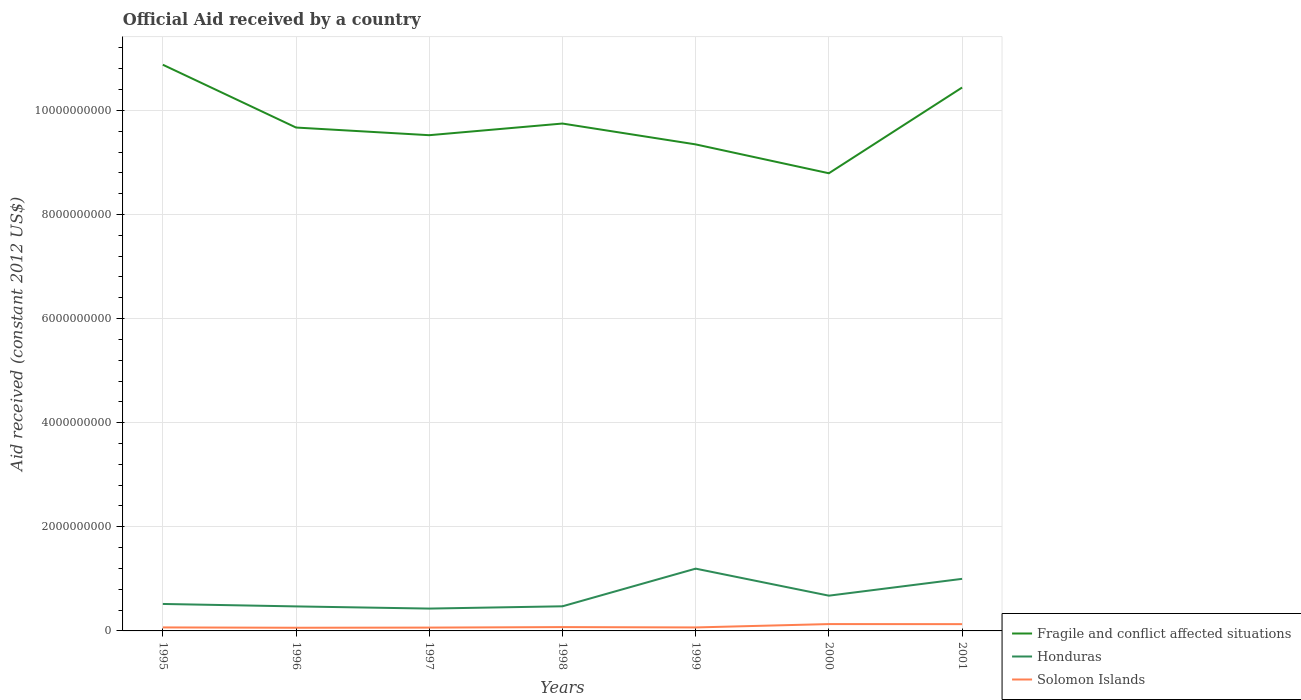How many different coloured lines are there?
Offer a terse response. 3. Does the line corresponding to Fragile and conflict affected situations intersect with the line corresponding to Solomon Islands?
Your response must be concise. No. Across all years, what is the maximum net official aid received in Honduras?
Give a very brief answer. 4.29e+08. What is the total net official aid received in Honduras in the graph?
Provide a succinct answer. 5.19e+08. What is the difference between the highest and the second highest net official aid received in Honduras?
Provide a succinct answer. 7.67e+08. How many lines are there?
Ensure brevity in your answer.  3. How many years are there in the graph?
Give a very brief answer. 7. Where does the legend appear in the graph?
Offer a terse response. Bottom right. How are the legend labels stacked?
Offer a terse response. Vertical. What is the title of the graph?
Your response must be concise. Official Aid received by a country. Does "Haiti" appear as one of the legend labels in the graph?
Your answer should be compact. No. What is the label or title of the Y-axis?
Make the answer very short. Aid received (constant 2012 US$). What is the Aid received (constant 2012 US$) of Fragile and conflict affected situations in 1995?
Provide a short and direct response. 1.09e+1. What is the Aid received (constant 2012 US$) of Honduras in 1995?
Your answer should be very brief. 5.18e+08. What is the Aid received (constant 2012 US$) in Solomon Islands in 1995?
Keep it short and to the point. 6.73e+07. What is the Aid received (constant 2012 US$) of Fragile and conflict affected situations in 1996?
Give a very brief answer. 9.67e+09. What is the Aid received (constant 2012 US$) of Honduras in 1996?
Your answer should be very brief. 4.71e+08. What is the Aid received (constant 2012 US$) of Solomon Islands in 1996?
Ensure brevity in your answer.  6.09e+07. What is the Aid received (constant 2012 US$) of Fragile and conflict affected situations in 1997?
Your response must be concise. 9.52e+09. What is the Aid received (constant 2012 US$) of Honduras in 1997?
Your answer should be very brief. 4.29e+08. What is the Aid received (constant 2012 US$) of Solomon Islands in 1997?
Offer a very short reply. 6.41e+07. What is the Aid received (constant 2012 US$) in Fragile and conflict affected situations in 1998?
Offer a very short reply. 9.75e+09. What is the Aid received (constant 2012 US$) of Honduras in 1998?
Your response must be concise. 4.73e+08. What is the Aid received (constant 2012 US$) of Solomon Islands in 1998?
Your answer should be compact. 7.36e+07. What is the Aid received (constant 2012 US$) in Fragile and conflict affected situations in 1999?
Your answer should be compact. 9.35e+09. What is the Aid received (constant 2012 US$) of Honduras in 1999?
Keep it short and to the point. 1.20e+09. What is the Aid received (constant 2012 US$) in Solomon Islands in 1999?
Provide a succinct answer. 6.69e+07. What is the Aid received (constant 2012 US$) of Fragile and conflict affected situations in 2000?
Provide a short and direct response. 8.79e+09. What is the Aid received (constant 2012 US$) of Honduras in 2000?
Your answer should be very brief. 6.77e+08. What is the Aid received (constant 2012 US$) of Solomon Islands in 2000?
Your response must be concise. 1.32e+08. What is the Aid received (constant 2012 US$) of Fragile and conflict affected situations in 2001?
Your response must be concise. 1.04e+1. What is the Aid received (constant 2012 US$) of Honduras in 2001?
Keep it short and to the point. 1.00e+09. What is the Aid received (constant 2012 US$) of Solomon Islands in 2001?
Keep it short and to the point. 1.30e+08. Across all years, what is the maximum Aid received (constant 2012 US$) of Fragile and conflict affected situations?
Make the answer very short. 1.09e+1. Across all years, what is the maximum Aid received (constant 2012 US$) in Honduras?
Ensure brevity in your answer.  1.20e+09. Across all years, what is the maximum Aid received (constant 2012 US$) of Solomon Islands?
Your answer should be very brief. 1.32e+08. Across all years, what is the minimum Aid received (constant 2012 US$) in Fragile and conflict affected situations?
Your response must be concise. 8.79e+09. Across all years, what is the minimum Aid received (constant 2012 US$) in Honduras?
Offer a terse response. 4.29e+08. Across all years, what is the minimum Aid received (constant 2012 US$) in Solomon Islands?
Keep it short and to the point. 6.09e+07. What is the total Aid received (constant 2012 US$) in Fragile and conflict affected situations in the graph?
Ensure brevity in your answer.  6.84e+1. What is the total Aid received (constant 2012 US$) in Honduras in the graph?
Give a very brief answer. 4.77e+09. What is the total Aid received (constant 2012 US$) in Solomon Islands in the graph?
Provide a short and direct response. 5.95e+08. What is the difference between the Aid received (constant 2012 US$) in Fragile and conflict affected situations in 1995 and that in 1996?
Provide a short and direct response. 1.21e+09. What is the difference between the Aid received (constant 2012 US$) in Honduras in 1995 and that in 1996?
Your answer should be very brief. 4.69e+07. What is the difference between the Aid received (constant 2012 US$) in Solomon Islands in 1995 and that in 1996?
Your answer should be compact. 6.45e+06. What is the difference between the Aid received (constant 2012 US$) in Fragile and conflict affected situations in 1995 and that in 1997?
Offer a terse response. 1.35e+09. What is the difference between the Aid received (constant 2012 US$) in Honduras in 1995 and that in 1997?
Your response must be concise. 8.87e+07. What is the difference between the Aid received (constant 2012 US$) of Solomon Islands in 1995 and that in 1997?
Your response must be concise. 3.24e+06. What is the difference between the Aid received (constant 2012 US$) in Fragile and conflict affected situations in 1995 and that in 1998?
Provide a short and direct response. 1.13e+09. What is the difference between the Aid received (constant 2012 US$) of Honduras in 1995 and that in 1998?
Your answer should be compact. 4.49e+07. What is the difference between the Aid received (constant 2012 US$) of Solomon Islands in 1995 and that in 1998?
Provide a short and direct response. -6.33e+06. What is the difference between the Aid received (constant 2012 US$) of Fragile and conflict affected situations in 1995 and that in 1999?
Offer a terse response. 1.53e+09. What is the difference between the Aid received (constant 2012 US$) in Honduras in 1995 and that in 1999?
Make the answer very short. -6.78e+08. What is the difference between the Aid received (constant 2012 US$) in Fragile and conflict affected situations in 1995 and that in 2000?
Keep it short and to the point. 2.08e+09. What is the difference between the Aid received (constant 2012 US$) in Honduras in 1995 and that in 2000?
Provide a succinct answer. -1.59e+08. What is the difference between the Aid received (constant 2012 US$) in Solomon Islands in 1995 and that in 2000?
Provide a short and direct response. -6.42e+07. What is the difference between the Aid received (constant 2012 US$) of Fragile and conflict affected situations in 1995 and that in 2001?
Keep it short and to the point. 4.38e+08. What is the difference between the Aid received (constant 2012 US$) in Honduras in 1995 and that in 2001?
Your answer should be compact. -4.82e+08. What is the difference between the Aid received (constant 2012 US$) in Solomon Islands in 1995 and that in 2001?
Your response must be concise. -6.29e+07. What is the difference between the Aid received (constant 2012 US$) in Fragile and conflict affected situations in 1996 and that in 1997?
Offer a very short reply. 1.47e+08. What is the difference between the Aid received (constant 2012 US$) in Honduras in 1996 and that in 1997?
Your response must be concise. 4.18e+07. What is the difference between the Aid received (constant 2012 US$) in Solomon Islands in 1996 and that in 1997?
Your response must be concise. -3.21e+06. What is the difference between the Aid received (constant 2012 US$) in Fragile and conflict affected situations in 1996 and that in 1998?
Offer a terse response. -7.68e+07. What is the difference between the Aid received (constant 2012 US$) in Solomon Islands in 1996 and that in 1998?
Provide a succinct answer. -1.28e+07. What is the difference between the Aid received (constant 2012 US$) in Fragile and conflict affected situations in 1996 and that in 1999?
Ensure brevity in your answer.  3.24e+08. What is the difference between the Aid received (constant 2012 US$) in Honduras in 1996 and that in 1999?
Make the answer very short. -7.25e+08. What is the difference between the Aid received (constant 2012 US$) in Solomon Islands in 1996 and that in 1999?
Your response must be concise. -6.04e+06. What is the difference between the Aid received (constant 2012 US$) in Fragile and conflict affected situations in 1996 and that in 2000?
Keep it short and to the point. 8.78e+08. What is the difference between the Aid received (constant 2012 US$) in Honduras in 1996 and that in 2000?
Provide a short and direct response. -2.06e+08. What is the difference between the Aid received (constant 2012 US$) in Solomon Islands in 1996 and that in 2000?
Your answer should be very brief. -7.07e+07. What is the difference between the Aid received (constant 2012 US$) of Fragile and conflict affected situations in 1996 and that in 2001?
Provide a succinct answer. -7.69e+08. What is the difference between the Aid received (constant 2012 US$) in Honduras in 1996 and that in 2001?
Offer a terse response. -5.29e+08. What is the difference between the Aid received (constant 2012 US$) in Solomon Islands in 1996 and that in 2001?
Provide a succinct answer. -6.93e+07. What is the difference between the Aid received (constant 2012 US$) of Fragile and conflict affected situations in 1997 and that in 1998?
Provide a succinct answer. -2.24e+08. What is the difference between the Aid received (constant 2012 US$) in Honduras in 1997 and that in 1998?
Offer a terse response. -4.38e+07. What is the difference between the Aid received (constant 2012 US$) of Solomon Islands in 1997 and that in 1998?
Give a very brief answer. -9.57e+06. What is the difference between the Aid received (constant 2012 US$) in Fragile and conflict affected situations in 1997 and that in 1999?
Ensure brevity in your answer.  1.77e+08. What is the difference between the Aid received (constant 2012 US$) of Honduras in 1997 and that in 1999?
Your answer should be compact. -7.67e+08. What is the difference between the Aid received (constant 2012 US$) in Solomon Islands in 1997 and that in 1999?
Offer a terse response. -2.83e+06. What is the difference between the Aid received (constant 2012 US$) of Fragile and conflict affected situations in 1997 and that in 2000?
Offer a terse response. 7.31e+08. What is the difference between the Aid received (constant 2012 US$) in Honduras in 1997 and that in 2000?
Ensure brevity in your answer.  -2.48e+08. What is the difference between the Aid received (constant 2012 US$) of Solomon Islands in 1997 and that in 2000?
Provide a short and direct response. -6.75e+07. What is the difference between the Aid received (constant 2012 US$) of Fragile and conflict affected situations in 1997 and that in 2001?
Your answer should be very brief. -9.16e+08. What is the difference between the Aid received (constant 2012 US$) of Honduras in 1997 and that in 2001?
Provide a succinct answer. -5.71e+08. What is the difference between the Aid received (constant 2012 US$) of Solomon Islands in 1997 and that in 2001?
Give a very brief answer. -6.61e+07. What is the difference between the Aid received (constant 2012 US$) of Fragile and conflict affected situations in 1998 and that in 1999?
Offer a terse response. 4.01e+08. What is the difference between the Aid received (constant 2012 US$) of Honduras in 1998 and that in 1999?
Give a very brief answer. -7.23e+08. What is the difference between the Aid received (constant 2012 US$) of Solomon Islands in 1998 and that in 1999?
Provide a short and direct response. 6.74e+06. What is the difference between the Aid received (constant 2012 US$) of Fragile and conflict affected situations in 1998 and that in 2000?
Ensure brevity in your answer.  9.55e+08. What is the difference between the Aid received (constant 2012 US$) of Honduras in 1998 and that in 2000?
Give a very brief answer. -2.04e+08. What is the difference between the Aid received (constant 2012 US$) in Solomon Islands in 1998 and that in 2000?
Make the answer very short. -5.79e+07. What is the difference between the Aid received (constant 2012 US$) of Fragile and conflict affected situations in 1998 and that in 2001?
Provide a short and direct response. -6.92e+08. What is the difference between the Aid received (constant 2012 US$) in Honduras in 1998 and that in 2001?
Ensure brevity in your answer.  -5.27e+08. What is the difference between the Aid received (constant 2012 US$) of Solomon Islands in 1998 and that in 2001?
Give a very brief answer. -5.66e+07. What is the difference between the Aid received (constant 2012 US$) in Fragile and conflict affected situations in 1999 and that in 2000?
Your answer should be compact. 5.54e+08. What is the difference between the Aid received (constant 2012 US$) in Honduras in 1999 and that in 2000?
Make the answer very short. 5.19e+08. What is the difference between the Aid received (constant 2012 US$) in Solomon Islands in 1999 and that in 2000?
Provide a short and direct response. -6.46e+07. What is the difference between the Aid received (constant 2012 US$) of Fragile and conflict affected situations in 1999 and that in 2001?
Offer a very short reply. -1.09e+09. What is the difference between the Aid received (constant 2012 US$) of Honduras in 1999 and that in 2001?
Offer a terse response. 1.96e+08. What is the difference between the Aid received (constant 2012 US$) in Solomon Islands in 1999 and that in 2001?
Offer a very short reply. -6.33e+07. What is the difference between the Aid received (constant 2012 US$) of Fragile and conflict affected situations in 2000 and that in 2001?
Offer a terse response. -1.65e+09. What is the difference between the Aid received (constant 2012 US$) of Honduras in 2000 and that in 2001?
Ensure brevity in your answer.  -3.23e+08. What is the difference between the Aid received (constant 2012 US$) in Solomon Islands in 2000 and that in 2001?
Keep it short and to the point. 1.33e+06. What is the difference between the Aid received (constant 2012 US$) in Fragile and conflict affected situations in 1995 and the Aid received (constant 2012 US$) in Honduras in 1996?
Your answer should be compact. 1.04e+1. What is the difference between the Aid received (constant 2012 US$) of Fragile and conflict affected situations in 1995 and the Aid received (constant 2012 US$) of Solomon Islands in 1996?
Your answer should be very brief. 1.08e+1. What is the difference between the Aid received (constant 2012 US$) in Honduras in 1995 and the Aid received (constant 2012 US$) in Solomon Islands in 1996?
Give a very brief answer. 4.57e+08. What is the difference between the Aid received (constant 2012 US$) of Fragile and conflict affected situations in 1995 and the Aid received (constant 2012 US$) of Honduras in 1997?
Your answer should be very brief. 1.04e+1. What is the difference between the Aid received (constant 2012 US$) in Fragile and conflict affected situations in 1995 and the Aid received (constant 2012 US$) in Solomon Islands in 1997?
Your response must be concise. 1.08e+1. What is the difference between the Aid received (constant 2012 US$) in Honduras in 1995 and the Aid received (constant 2012 US$) in Solomon Islands in 1997?
Provide a succinct answer. 4.54e+08. What is the difference between the Aid received (constant 2012 US$) in Fragile and conflict affected situations in 1995 and the Aid received (constant 2012 US$) in Honduras in 1998?
Keep it short and to the point. 1.04e+1. What is the difference between the Aid received (constant 2012 US$) of Fragile and conflict affected situations in 1995 and the Aid received (constant 2012 US$) of Solomon Islands in 1998?
Offer a terse response. 1.08e+1. What is the difference between the Aid received (constant 2012 US$) of Honduras in 1995 and the Aid received (constant 2012 US$) of Solomon Islands in 1998?
Keep it short and to the point. 4.44e+08. What is the difference between the Aid received (constant 2012 US$) in Fragile and conflict affected situations in 1995 and the Aid received (constant 2012 US$) in Honduras in 1999?
Provide a succinct answer. 9.68e+09. What is the difference between the Aid received (constant 2012 US$) of Fragile and conflict affected situations in 1995 and the Aid received (constant 2012 US$) of Solomon Islands in 1999?
Your answer should be compact. 1.08e+1. What is the difference between the Aid received (constant 2012 US$) of Honduras in 1995 and the Aid received (constant 2012 US$) of Solomon Islands in 1999?
Offer a terse response. 4.51e+08. What is the difference between the Aid received (constant 2012 US$) of Fragile and conflict affected situations in 1995 and the Aid received (constant 2012 US$) of Honduras in 2000?
Your answer should be very brief. 1.02e+1. What is the difference between the Aid received (constant 2012 US$) in Fragile and conflict affected situations in 1995 and the Aid received (constant 2012 US$) in Solomon Islands in 2000?
Offer a very short reply. 1.07e+1. What is the difference between the Aid received (constant 2012 US$) of Honduras in 1995 and the Aid received (constant 2012 US$) of Solomon Islands in 2000?
Ensure brevity in your answer.  3.86e+08. What is the difference between the Aid received (constant 2012 US$) of Fragile and conflict affected situations in 1995 and the Aid received (constant 2012 US$) of Honduras in 2001?
Ensure brevity in your answer.  9.88e+09. What is the difference between the Aid received (constant 2012 US$) in Fragile and conflict affected situations in 1995 and the Aid received (constant 2012 US$) in Solomon Islands in 2001?
Your answer should be very brief. 1.07e+1. What is the difference between the Aid received (constant 2012 US$) of Honduras in 1995 and the Aid received (constant 2012 US$) of Solomon Islands in 2001?
Ensure brevity in your answer.  3.88e+08. What is the difference between the Aid received (constant 2012 US$) in Fragile and conflict affected situations in 1996 and the Aid received (constant 2012 US$) in Honduras in 1997?
Keep it short and to the point. 9.24e+09. What is the difference between the Aid received (constant 2012 US$) of Fragile and conflict affected situations in 1996 and the Aid received (constant 2012 US$) of Solomon Islands in 1997?
Offer a very short reply. 9.61e+09. What is the difference between the Aid received (constant 2012 US$) in Honduras in 1996 and the Aid received (constant 2012 US$) in Solomon Islands in 1997?
Your answer should be compact. 4.07e+08. What is the difference between the Aid received (constant 2012 US$) of Fragile and conflict affected situations in 1996 and the Aid received (constant 2012 US$) of Honduras in 1998?
Keep it short and to the point. 9.20e+09. What is the difference between the Aid received (constant 2012 US$) in Fragile and conflict affected situations in 1996 and the Aid received (constant 2012 US$) in Solomon Islands in 1998?
Your answer should be very brief. 9.60e+09. What is the difference between the Aid received (constant 2012 US$) of Honduras in 1996 and the Aid received (constant 2012 US$) of Solomon Islands in 1998?
Provide a short and direct response. 3.97e+08. What is the difference between the Aid received (constant 2012 US$) of Fragile and conflict affected situations in 1996 and the Aid received (constant 2012 US$) of Honduras in 1999?
Your answer should be compact. 8.47e+09. What is the difference between the Aid received (constant 2012 US$) of Fragile and conflict affected situations in 1996 and the Aid received (constant 2012 US$) of Solomon Islands in 1999?
Provide a succinct answer. 9.60e+09. What is the difference between the Aid received (constant 2012 US$) of Honduras in 1996 and the Aid received (constant 2012 US$) of Solomon Islands in 1999?
Provide a short and direct response. 4.04e+08. What is the difference between the Aid received (constant 2012 US$) in Fragile and conflict affected situations in 1996 and the Aid received (constant 2012 US$) in Honduras in 2000?
Provide a short and direct response. 8.99e+09. What is the difference between the Aid received (constant 2012 US$) of Fragile and conflict affected situations in 1996 and the Aid received (constant 2012 US$) of Solomon Islands in 2000?
Make the answer very short. 9.54e+09. What is the difference between the Aid received (constant 2012 US$) of Honduras in 1996 and the Aid received (constant 2012 US$) of Solomon Islands in 2000?
Provide a succinct answer. 3.40e+08. What is the difference between the Aid received (constant 2012 US$) of Fragile and conflict affected situations in 1996 and the Aid received (constant 2012 US$) of Honduras in 2001?
Provide a short and direct response. 8.67e+09. What is the difference between the Aid received (constant 2012 US$) in Fragile and conflict affected situations in 1996 and the Aid received (constant 2012 US$) in Solomon Islands in 2001?
Your response must be concise. 9.54e+09. What is the difference between the Aid received (constant 2012 US$) of Honduras in 1996 and the Aid received (constant 2012 US$) of Solomon Islands in 2001?
Give a very brief answer. 3.41e+08. What is the difference between the Aid received (constant 2012 US$) in Fragile and conflict affected situations in 1997 and the Aid received (constant 2012 US$) in Honduras in 1998?
Give a very brief answer. 9.05e+09. What is the difference between the Aid received (constant 2012 US$) of Fragile and conflict affected situations in 1997 and the Aid received (constant 2012 US$) of Solomon Islands in 1998?
Give a very brief answer. 9.45e+09. What is the difference between the Aid received (constant 2012 US$) of Honduras in 1997 and the Aid received (constant 2012 US$) of Solomon Islands in 1998?
Offer a very short reply. 3.56e+08. What is the difference between the Aid received (constant 2012 US$) of Fragile and conflict affected situations in 1997 and the Aid received (constant 2012 US$) of Honduras in 1999?
Provide a succinct answer. 8.33e+09. What is the difference between the Aid received (constant 2012 US$) of Fragile and conflict affected situations in 1997 and the Aid received (constant 2012 US$) of Solomon Islands in 1999?
Keep it short and to the point. 9.46e+09. What is the difference between the Aid received (constant 2012 US$) in Honduras in 1997 and the Aid received (constant 2012 US$) in Solomon Islands in 1999?
Your answer should be compact. 3.62e+08. What is the difference between the Aid received (constant 2012 US$) in Fragile and conflict affected situations in 1997 and the Aid received (constant 2012 US$) in Honduras in 2000?
Your answer should be compact. 8.85e+09. What is the difference between the Aid received (constant 2012 US$) of Fragile and conflict affected situations in 1997 and the Aid received (constant 2012 US$) of Solomon Islands in 2000?
Make the answer very short. 9.39e+09. What is the difference between the Aid received (constant 2012 US$) of Honduras in 1997 and the Aid received (constant 2012 US$) of Solomon Islands in 2000?
Offer a very short reply. 2.98e+08. What is the difference between the Aid received (constant 2012 US$) in Fragile and conflict affected situations in 1997 and the Aid received (constant 2012 US$) in Honduras in 2001?
Offer a terse response. 8.52e+09. What is the difference between the Aid received (constant 2012 US$) of Fragile and conflict affected situations in 1997 and the Aid received (constant 2012 US$) of Solomon Islands in 2001?
Your answer should be very brief. 9.39e+09. What is the difference between the Aid received (constant 2012 US$) in Honduras in 1997 and the Aid received (constant 2012 US$) in Solomon Islands in 2001?
Provide a succinct answer. 2.99e+08. What is the difference between the Aid received (constant 2012 US$) in Fragile and conflict affected situations in 1998 and the Aid received (constant 2012 US$) in Honduras in 1999?
Offer a terse response. 8.55e+09. What is the difference between the Aid received (constant 2012 US$) of Fragile and conflict affected situations in 1998 and the Aid received (constant 2012 US$) of Solomon Islands in 1999?
Give a very brief answer. 9.68e+09. What is the difference between the Aid received (constant 2012 US$) in Honduras in 1998 and the Aid received (constant 2012 US$) in Solomon Islands in 1999?
Make the answer very short. 4.06e+08. What is the difference between the Aid received (constant 2012 US$) in Fragile and conflict affected situations in 1998 and the Aid received (constant 2012 US$) in Honduras in 2000?
Your answer should be very brief. 9.07e+09. What is the difference between the Aid received (constant 2012 US$) of Fragile and conflict affected situations in 1998 and the Aid received (constant 2012 US$) of Solomon Islands in 2000?
Offer a terse response. 9.62e+09. What is the difference between the Aid received (constant 2012 US$) of Honduras in 1998 and the Aid received (constant 2012 US$) of Solomon Islands in 2000?
Your answer should be very brief. 3.42e+08. What is the difference between the Aid received (constant 2012 US$) of Fragile and conflict affected situations in 1998 and the Aid received (constant 2012 US$) of Honduras in 2001?
Provide a short and direct response. 8.75e+09. What is the difference between the Aid received (constant 2012 US$) of Fragile and conflict affected situations in 1998 and the Aid received (constant 2012 US$) of Solomon Islands in 2001?
Offer a very short reply. 9.62e+09. What is the difference between the Aid received (constant 2012 US$) of Honduras in 1998 and the Aid received (constant 2012 US$) of Solomon Islands in 2001?
Make the answer very short. 3.43e+08. What is the difference between the Aid received (constant 2012 US$) of Fragile and conflict affected situations in 1999 and the Aid received (constant 2012 US$) of Honduras in 2000?
Provide a short and direct response. 8.67e+09. What is the difference between the Aid received (constant 2012 US$) of Fragile and conflict affected situations in 1999 and the Aid received (constant 2012 US$) of Solomon Islands in 2000?
Keep it short and to the point. 9.21e+09. What is the difference between the Aid received (constant 2012 US$) in Honduras in 1999 and the Aid received (constant 2012 US$) in Solomon Islands in 2000?
Provide a short and direct response. 1.06e+09. What is the difference between the Aid received (constant 2012 US$) of Fragile and conflict affected situations in 1999 and the Aid received (constant 2012 US$) of Honduras in 2001?
Offer a terse response. 8.35e+09. What is the difference between the Aid received (constant 2012 US$) of Fragile and conflict affected situations in 1999 and the Aid received (constant 2012 US$) of Solomon Islands in 2001?
Provide a succinct answer. 9.22e+09. What is the difference between the Aid received (constant 2012 US$) of Honduras in 1999 and the Aid received (constant 2012 US$) of Solomon Islands in 2001?
Your answer should be very brief. 1.07e+09. What is the difference between the Aid received (constant 2012 US$) in Fragile and conflict affected situations in 2000 and the Aid received (constant 2012 US$) in Honduras in 2001?
Your answer should be very brief. 7.79e+09. What is the difference between the Aid received (constant 2012 US$) in Fragile and conflict affected situations in 2000 and the Aid received (constant 2012 US$) in Solomon Islands in 2001?
Offer a very short reply. 8.66e+09. What is the difference between the Aid received (constant 2012 US$) of Honduras in 2000 and the Aid received (constant 2012 US$) of Solomon Islands in 2001?
Provide a short and direct response. 5.47e+08. What is the average Aid received (constant 2012 US$) in Fragile and conflict affected situations per year?
Offer a very short reply. 9.77e+09. What is the average Aid received (constant 2012 US$) in Honduras per year?
Your answer should be very brief. 6.81e+08. What is the average Aid received (constant 2012 US$) of Solomon Islands per year?
Your answer should be compact. 8.49e+07. In the year 1995, what is the difference between the Aid received (constant 2012 US$) in Fragile and conflict affected situations and Aid received (constant 2012 US$) in Honduras?
Keep it short and to the point. 1.04e+1. In the year 1995, what is the difference between the Aid received (constant 2012 US$) in Fragile and conflict affected situations and Aid received (constant 2012 US$) in Solomon Islands?
Offer a terse response. 1.08e+1. In the year 1995, what is the difference between the Aid received (constant 2012 US$) in Honduras and Aid received (constant 2012 US$) in Solomon Islands?
Provide a succinct answer. 4.51e+08. In the year 1996, what is the difference between the Aid received (constant 2012 US$) of Fragile and conflict affected situations and Aid received (constant 2012 US$) of Honduras?
Give a very brief answer. 9.20e+09. In the year 1996, what is the difference between the Aid received (constant 2012 US$) in Fragile and conflict affected situations and Aid received (constant 2012 US$) in Solomon Islands?
Ensure brevity in your answer.  9.61e+09. In the year 1996, what is the difference between the Aid received (constant 2012 US$) in Honduras and Aid received (constant 2012 US$) in Solomon Islands?
Your answer should be compact. 4.10e+08. In the year 1997, what is the difference between the Aid received (constant 2012 US$) of Fragile and conflict affected situations and Aid received (constant 2012 US$) of Honduras?
Make the answer very short. 9.09e+09. In the year 1997, what is the difference between the Aid received (constant 2012 US$) of Fragile and conflict affected situations and Aid received (constant 2012 US$) of Solomon Islands?
Provide a succinct answer. 9.46e+09. In the year 1997, what is the difference between the Aid received (constant 2012 US$) of Honduras and Aid received (constant 2012 US$) of Solomon Islands?
Make the answer very short. 3.65e+08. In the year 1998, what is the difference between the Aid received (constant 2012 US$) of Fragile and conflict affected situations and Aid received (constant 2012 US$) of Honduras?
Your response must be concise. 9.27e+09. In the year 1998, what is the difference between the Aid received (constant 2012 US$) of Fragile and conflict affected situations and Aid received (constant 2012 US$) of Solomon Islands?
Offer a terse response. 9.67e+09. In the year 1998, what is the difference between the Aid received (constant 2012 US$) of Honduras and Aid received (constant 2012 US$) of Solomon Islands?
Ensure brevity in your answer.  3.99e+08. In the year 1999, what is the difference between the Aid received (constant 2012 US$) in Fragile and conflict affected situations and Aid received (constant 2012 US$) in Honduras?
Your answer should be compact. 8.15e+09. In the year 1999, what is the difference between the Aid received (constant 2012 US$) of Fragile and conflict affected situations and Aid received (constant 2012 US$) of Solomon Islands?
Keep it short and to the point. 9.28e+09. In the year 1999, what is the difference between the Aid received (constant 2012 US$) of Honduras and Aid received (constant 2012 US$) of Solomon Islands?
Provide a short and direct response. 1.13e+09. In the year 2000, what is the difference between the Aid received (constant 2012 US$) in Fragile and conflict affected situations and Aid received (constant 2012 US$) in Honduras?
Keep it short and to the point. 8.11e+09. In the year 2000, what is the difference between the Aid received (constant 2012 US$) of Fragile and conflict affected situations and Aid received (constant 2012 US$) of Solomon Islands?
Keep it short and to the point. 8.66e+09. In the year 2000, what is the difference between the Aid received (constant 2012 US$) of Honduras and Aid received (constant 2012 US$) of Solomon Islands?
Offer a very short reply. 5.46e+08. In the year 2001, what is the difference between the Aid received (constant 2012 US$) of Fragile and conflict affected situations and Aid received (constant 2012 US$) of Honduras?
Your answer should be compact. 9.44e+09. In the year 2001, what is the difference between the Aid received (constant 2012 US$) in Fragile and conflict affected situations and Aid received (constant 2012 US$) in Solomon Islands?
Provide a succinct answer. 1.03e+1. In the year 2001, what is the difference between the Aid received (constant 2012 US$) in Honduras and Aid received (constant 2012 US$) in Solomon Islands?
Your answer should be very brief. 8.70e+08. What is the ratio of the Aid received (constant 2012 US$) of Fragile and conflict affected situations in 1995 to that in 1996?
Offer a very short reply. 1.12. What is the ratio of the Aid received (constant 2012 US$) of Honduras in 1995 to that in 1996?
Ensure brevity in your answer.  1.1. What is the ratio of the Aid received (constant 2012 US$) of Solomon Islands in 1995 to that in 1996?
Keep it short and to the point. 1.11. What is the ratio of the Aid received (constant 2012 US$) in Fragile and conflict affected situations in 1995 to that in 1997?
Your answer should be compact. 1.14. What is the ratio of the Aid received (constant 2012 US$) in Honduras in 1995 to that in 1997?
Your response must be concise. 1.21. What is the ratio of the Aid received (constant 2012 US$) of Solomon Islands in 1995 to that in 1997?
Provide a short and direct response. 1.05. What is the ratio of the Aid received (constant 2012 US$) in Fragile and conflict affected situations in 1995 to that in 1998?
Ensure brevity in your answer.  1.12. What is the ratio of the Aid received (constant 2012 US$) of Honduras in 1995 to that in 1998?
Make the answer very short. 1.09. What is the ratio of the Aid received (constant 2012 US$) of Solomon Islands in 1995 to that in 1998?
Offer a terse response. 0.91. What is the ratio of the Aid received (constant 2012 US$) of Fragile and conflict affected situations in 1995 to that in 1999?
Offer a terse response. 1.16. What is the ratio of the Aid received (constant 2012 US$) in Honduras in 1995 to that in 1999?
Ensure brevity in your answer.  0.43. What is the ratio of the Aid received (constant 2012 US$) in Solomon Islands in 1995 to that in 1999?
Make the answer very short. 1.01. What is the ratio of the Aid received (constant 2012 US$) in Fragile and conflict affected situations in 1995 to that in 2000?
Keep it short and to the point. 1.24. What is the ratio of the Aid received (constant 2012 US$) in Honduras in 1995 to that in 2000?
Keep it short and to the point. 0.76. What is the ratio of the Aid received (constant 2012 US$) in Solomon Islands in 1995 to that in 2000?
Offer a very short reply. 0.51. What is the ratio of the Aid received (constant 2012 US$) of Fragile and conflict affected situations in 1995 to that in 2001?
Provide a succinct answer. 1.04. What is the ratio of the Aid received (constant 2012 US$) of Honduras in 1995 to that in 2001?
Provide a succinct answer. 0.52. What is the ratio of the Aid received (constant 2012 US$) of Solomon Islands in 1995 to that in 2001?
Provide a succinct answer. 0.52. What is the ratio of the Aid received (constant 2012 US$) of Fragile and conflict affected situations in 1996 to that in 1997?
Provide a short and direct response. 1.02. What is the ratio of the Aid received (constant 2012 US$) in Honduras in 1996 to that in 1997?
Ensure brevity in your answer.  1.1. What is the ratio of the Aid received (constant 2012 US$) of Solomon Islands in 1996 to that in 1997?
Ensure brevity in your answer.  0.95. What is the ratio of the Aid received (constant 2012 US$) in Honduras in 1996 to that in 1998?
Make the answer very short. 1. What is the ratio of the Aid received (constant 2012 US$) in Solomon Islands in 1996 to that in 1998?
Give a very brief answer. 0.83. What is the ratio of the Aid received (constant 2012 US$) of Fragile and conflict affected situations in 1996 to that in 1999?
Provide a short and direct response. 1.03. What is the ratio of the Aid received (constant 2012 US$) of Honduras in 1996 to that in 1999?
Keep it short and to the point. 0.39. What is the ratio of the Aid received (constant 2012 US$) of Solomon Islands in 1996 to that in 1999?
Your response must be concise. 0.91. What is the ratio of the Aid received (constant 2012 US$) in Fragile and conflict affected situations in 1996 to that in 2000?
Ensure brevity in your answer.  1.1. What is the ratio of the Aid received (constant 2012 US$) in Honduras in 1996 to that in 2000?
Ensure brevity in your answer.  0.7. What is the ratio of the Aid received (constant 2012 US$) in Solomon Islands in 1996 to that in 2000?
Provide a short and direct response. 0.46. What is the ratio of the Aid received (constant 2012 US$) of Fragile and conflict affected situations in 1996 to that in 2001?
Ensure brevity in your answer.  0.93. What is the ratio of the Aid received (constant 2012 US$) of Honduras in 1996 to that in 2001?
Your response must be concise. 0.47. What is the ratio of the Aid received (constant 2012 US$) in Solomon Islands in 1996 to that in 2001?
Keep it short and to the point. 0.47. What is the ratio of the Aid received (constant 2012 US$) of Honduras in 1997 to that in 1998?
Make the answer very short. 0.91. What is the ratio of the Aid received (constant 2012 US$) of Solomon Islands in 1997 to that in 1998?
Give a very brief answer. 0.87. What is the ratio of the Aid received (constant 2012 US$) in Fragile and conflict affected situations in 1997 to that in 1999?
Provide a short and direct response. 1.02. What is the ratio of the Aid received (constant 2012 US$) of Honduras in 1997 to that in 1999?
Your response must be concise. 0.36. What is the ratio of the Aid received (constant 2012 US$) of Solomon Islands in 1997 to that in 1999?
Offer a very short reply. 0.96. What is the ratio of the Aid received (constant 2012 US$) of Fragile and conflict affected situations in 1997 to that in 2000?
Offer a very short reply. 1.08. What is the ratio of the Aid received (constant 2012 US$) in Honduras in 1997 to that in 2000?
Your response must be concise. 0.63. What is the ratio of the Aid received (constant 2012 US$) of Solomon Islands in 1997 to that in 2000?
Provide a succinct answer. 0.49. What is the ratio of the Aid received (constant 2012 US$) of Fragile and conflict affected situations in 1997 to that in 2001?
Keep it short and to the point. 0.91. What is the ratio of the Aid received (constant 2012 US$) in Honduras in 1997 to that in 2001?
Offer a very short reply. 0.43. What is the ratio of the Aid received (constant 2012 US$) in Solomon Islands in 1997 to that in 2001?
Offer a terse response. 0.49. What is the ratio of the Aid received (constant 2012 US$) in Fragile and conflict affected situations in 1998 to that in 1999?
Your response must be concise. 1.04. What is the ratio of the Aid received (constant 2012 US$) in Honduras in 1998 to that in 1999?
Ensure brevity in your answer.  0.4. What is the ratio of the Aid received (constant 2012 US$) in Solomon Islands in 1998 to that in 1999?
Make the answer very short. 1.1. What is the ratio of the Aid received (constant 2012 US$) of Fragile and conflict affected situations in 1998 to that in 2000?
Ensure brevity in your answer.  1.11. What is the ratio of the Aid received (constant 2012 US$) of Honduras in 1998 to that in 2000?
Your response must be concise. 0.7. What is the ratio of the Aid received (constant 2012 US$) in Solomon Islands in 1998 to that in 2000?
Make the answer very short. 0.56. What is the ratio of the Aid received (constant 2012 US$) in Fragile and conflict affected situations in 1998 to that in 2001?
Your answer should be compact. 0.93. What is the ratio of the Aid received (constant 2012 US$) in Honduras in 1998 to that in 2001?
Keep it short and to the point. 0.47. What is the ratio of the Aid received (constant 2012 US$) in Solomon Islands in 1998 to that in 2001?
Keep it short and to the point. 0.57. What is the ratio of the Aid received (constant 2012 US$) of Fragile and conflict affected situations in 1999 to that in 2000?
Provide a succinct answer. 1.06. What is the ratio of the Aid received (constant 2012 US$) of Honduras in 1999 to that in 2000?
Offer a very short reply. 1.77. What is the ratio of the Aid received (constant 2012 US$) in Solomon Islands in 1999 to that in 2000?
Make the answer very short. 0.51. What is the ratio of the Aid received (constant 2012 US$) in Fragile and conflict affected situations in 1999 to that in 2001?
Offer a very short reply. 0.9. What is the ratio of the Aid received (constant 2012 US$) in Honduras in 1999 to that in 2001?
Give a very brief answer. 1.2. What is the ratio of the Aid received (constant 2012 US$) of Solomon Islands in 1999 to that in 2001?
Keep it short and to the point. 0.51. What is the ratio of the Aid received (constant 2012 US$) of Fragile and conflict affected situations in 2000 to that in 2001?
Offer a terse response. 0.84. What is the ratio of the Aid received (constant 2012 US$) in Honduras in 2000 to that in 2001?
Your answer should be very brief. 0.68. What is the ratio of the Aid received (constant 2012 US$) of Solomon Islands in 2000 to that in 2001?
Offer a very short reply. 1.01. What is the difference between the highest and the second highest Aid received (constant 2012 US$) in Fragile and conflict affected situations?
Make the answer very short. 4.38e+08. What is the difference between the highest and the second highest Aid received (constant 2012 US$) of Honduras?
Make the answer very short. 1.96e+08. What is the difference between the highest and the second highest Aid received (constant 2012 US$) in Solomon Islands?
Your response must be concise. 1.33e+06. What is the difference between the highest and the lowest Aid received (constant 2012 US$) in Fragile and conflict affected situations?
Offer a terse response. 2.08e+09. What is the difference between the highest and the lowest Aid received (constant 2012 US$) of Honduras?
Ensure brevity in your answer.  7.67e+08. What is the difference between the highest and the lowest Aid received (constant 2012 US$) of Solomon Islands?
Provide a short and direct response. 7.07e+07. 